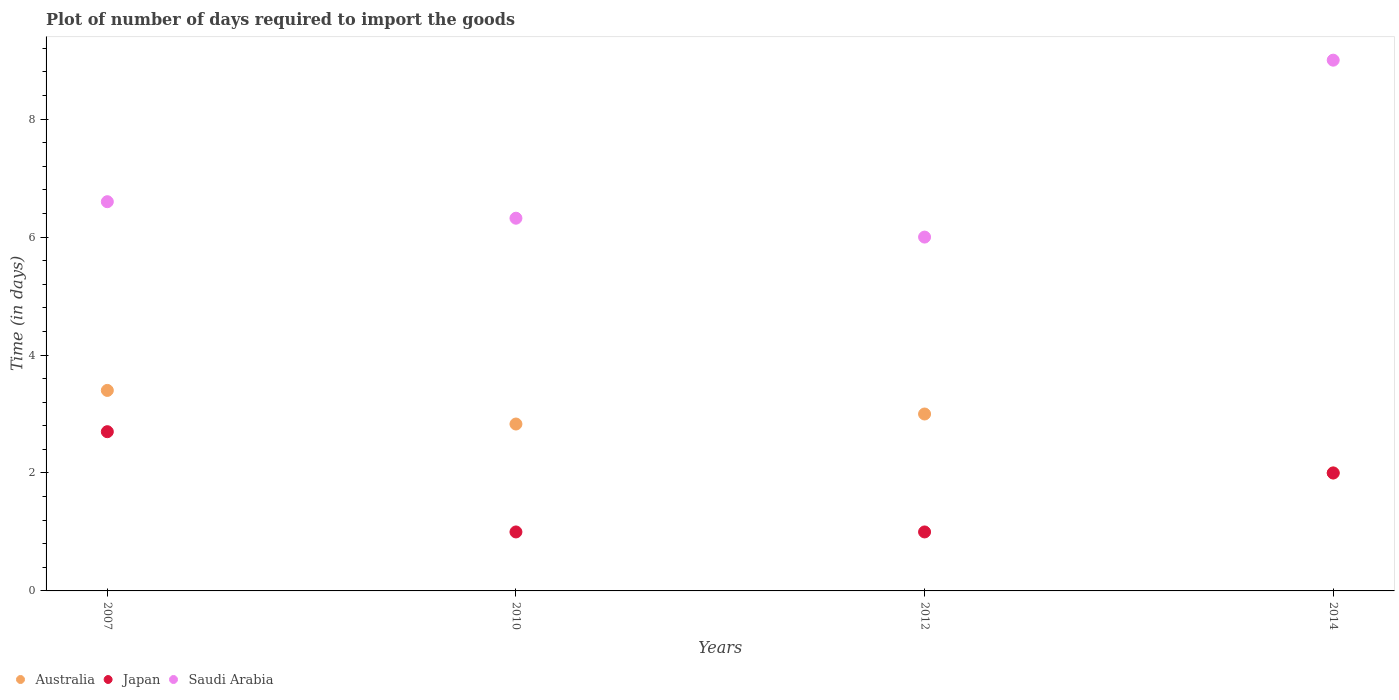How many different coloured dotlines are there?
Provide a short and direct response. 3. What is the time required to import goods in Australia in 2012?
Your answer should be very brief. 3. In which year was the time required to import goods in Australia minimum?
Provide a short and direct response. 2014. What is the total time required to import goods in Saudi Arabia in the graph?
Make the answer very short. 27.92. What is the difference between the time required to import goods in Japan in 2010 and that in 2014?
Offer a terse response. -1. What is the average time required to import goods in Saudi Arabia per year?
Your answer should be compact. 6.98. In the year 2012, what is the difference between the time required to import goods in Japan and time required to import goods in Saudi Arabia?
Ensure brevity in your answer.  -5. In how many years, is the time required to import goods in Australia greater than 4 days?
Provide a succinct answer. 0. What is the ratio of the time required to import goods in Saudi Arabia in 2007 to that in 2012?
Your answer should be compact. 1.1. Is the difference between the time required to import goods in Japan in 2010 and 2012 greater than the difference between the time required to import goods in Saudi Arabia in 2010 and 2012?
Provide a short and direct response. No. What is the difference between the highest and the second highest time required to import goods in Japan?
Offer a very short reply. 0.7. Is the sum of the time required to import goods in Saudi Arabia in 2007 and 2010 greater than the maximum time required to import goods in Australia across all years?
Provide a succinct answer. Yes. Is it the case that in every year, the sum of the time required to import goods in Australia and time required to import goods in Saudi Arabia  is greater than the time required to import goods in Japan?
Offer a very short reply. Yes. How many dotlines are there?
Give a very brief answer. 3. What is the difference between two consecutive major ticks on the Y-axis?
Offer a terse response. 2. Where does the legend appear in the graph?
Keep it short and to the point. Bottom left. How are the legend labels stacked?
Ensure brevity in your answer.  Horizontal. What is the title of the graph?
Your answer should be very brief. Plot of number of days required to import the goods. Does "High income: nonOECD" appear as one of the legend labels in the graph?
Give a very brief answer. No. What is the label or title of the Y-axis?
Offer a very short reply. Time (in days). What is the Time (in days) in Saudi Arabia in 2007?
Offer a terse response. 6.6. What is the Time (in days) in Australia in 2010?
Your answer should be very brief. 2.83. What is the Time (in days) of Japan in 2010?
Provide a short and direct response. 1. What is the Time (in days) in Saudi Arabia in 2010?
Make the answer very short. 6.32. What is the Time (in days) in Australia in 2012?
Give a very brief answer. 3. What is the Time (in days) in Japan in 2012?
Your answer should be very brief. 1. Across all years, what is the maximum Time (in days) in Saudi Arabia?
Ensure brevity in your answer.  9. Across all years, what is the minimum Time (in days) in Japan?
Give a very brief answer. 1. What is the total Time (in days) in Australia in the graph?
Give a very brief answer. 11.23. What is the total Time (in days) in Saudi Arabia in the graph?
Your answer should be very brief. 27.92. What is the difference between the Time (in days) in Australia in 2007 and that in 2010?
Offer a terse response. 0.57. What is the difference between the Time (in days) of Japan in 2007 and that in 2010?
Offer a very short reply. 1.7. What is the difference between the Time (in days) in Saudi Arabia in 2007 and that in 2010?
Provide a short and direct response. 0.28. What is the difference between the Time (in days) in Australia in 2007 and that in 2012?
Give a very brief answer. 0.4. What is the difference between the Time (in days) in Australia in 2007 and that in 2014?
Your answer should be very brief. 1.4. What is the difference between the Time (in days) of Saudi Arabia in 2007 and that in 2014?
Your answer should be compact. -2.4. What is the difference between the Time (in days) of Australia in 2010 and that in 2012?
Your answer should be compact. -0.17. What is the difference between the Time (in days) in Japan in 2010 and that in 2012?
Provide a succinct answer. 0. What is the difference between the Time (in days) in Saudi Arabia in 2010 and that in 2012?
Your answer should be very brief. 0.32. What is the difference between the Time (in days) in Australia in 2010 and that in 2014?
Your response must be concise. 0.83. What is the difference between the Time (in days) of Japan in 2010 and that in 2014?
Your response must be concise. -1. What is the difference between the Time (in days) of Saudi Arabia in 2010 and that in 2014?
Offer a very short reply. -2.68. What is the difference between the Time (in days) of Japan in 2012 and that in 2014?
Provide a short and direct response. -1. What is the difference between the Time (in days) in Australia in 2007 and the Time (in days) in Saudi Arabia in 2010?
Make the answer very short. -2.92. What is the difference between the Time (in days) in Japan in 2007 and the Time (in days) in Saudi Arabia in 2010?
Your answer should be very brief. -3.62. What is the difference between the Time (in days) of Australia in 2007 and the Time (in days) of Japan in 2012?
Keep it short and to the point. 2.4. What is the difference between the Time (in days) in Japan in 2007 and the Time (in days) in Saudi Arabia in 2014?
Your answer should be very brief. -6.3. What is the difference between the Time (in days) of Australia in 2010 and the Time (in days) of Japan in 2012?
Offer a terse response. 1.83. What is the difference between the Time (in days) of Australia in 2010 and the Time (in days) of Saudi Arabia in 2012?
Your response must be concise. -3.17. What is the difference between the Time (in days) of Japan in 2010 and the Time (in days) of Saudi Arabia in 2012?
Your response must be concise. -5. What is the difference between the Time (in days) in Australia in 2010 and the Time (in days) in Japan in 2014?
Make the answer very short. 0.83. What is the difference between the Time (in days) in Australia in 2010 and the Time (in days) in Saudi Arabia in 2014?
Keep it short and to the point. -6.17. What is the difference between the Time (in days) of Australia in 2012 and the Time (in days) of Japan in 2014?
Your answer should be very brief. 1. What is the difference between the Time (in days) of Australia in 2012 and the Time (in days) of Saudi Arabia in 2014?
Keep it short and to the point. -6. What is the average Time (in days) in Australia per year?
Offer a terse response. 2.81. What is the average Time (in days) in Japan per year?
Ensure brevity in your answer.  1.68. What is the average Time (in days) of Saudi Arabia per year?
Provide a succinct answer. 6.98. In the year 2010, what is the difference between the Time (in days) of Australia and Time (in days) of Japan?
Offer a very short reply. 1.83. In the year 2010, what is the difference between the Time (in days) in Australia and Time (in days) in Saudi Arabia?
Provide a succinct answer. -3.49. In the year 2010, what is the difference between the Time (in days) in Japan and Time (in days) in Saudi Arabia?
Keep it short and to the point. -5.32. In the year 2012, what is the difference between the Time (in days) in Australia and Time (in days) in Japan?
Give a very brief answer. 2. In the year 2012, what is the difference between the Time (in days) of Australia and Time (in days) of Saudi Arabia?
Provide a succinct answer. -3. In the year 2012, what is the difference between the Time (in days) of Japan and Time (in days) of Saudi Arabia?
Ensure brevity in your answer.  -5. In the year 2014, what is the difference between the Time (in days) in Australia and Time (in days) in Saudi Arabia?
Offer a very short reply. -7. What is the ratio of the Time (in days) of Australia in 2007 to that in 2010?
Make the answer very short. 1.2. What is the ratio of the Time (in days) in Japan in 2007 to that in 2010?
Keep it short and to the point. 2.7. What is the ratio of the Time (in days) of Saudi Arabia in 2007 to that in 2010?
Offer a very short reply. 1.04. What is the ratio of the Time (in days) of Australia in 2007 to that in 2012?
Offer a very short reply. 1.13. What is the ratio of the Time (in days) in Japan in 2007 to that in 2012?
Your response must be concise. 2.7. What is the ratio of the Time (in days) of Saudi Arabia in 2007 to that in 2012?
Your answer should be very brief. 1.1. What is the ratio of the Time (in days) in Australia in 2007 to that in 2014?
Your response must be concise. 1.7. What is the ratio of the Time (in days) of Japan in 2007 to that in 2014?
Your response must be concise. 1.35. What is the ratio of the Time (in days) of Saudi Arabia in 2007 to that in 2014?
Give a very brief answer. 0.73. What is the ratio of the Time (in days) of Australia in 2010 to that in 2012?
Provide a succinct answer. 0.94. What is the ratio of the Time (in days) of Saudi Arabia in 2010 to that in 2012?
Make the answer very short. 1.05. What is the ratio of the Time (in days) of Australia in 2010 to that in 2014?
Your answer should be compact. 1.42. What is the ratio of the Time (in days) in Saudi Arabia in 2010 to that in 2014?
Give a very brief answer. 0.7. What is the ratio of the Time (in days) of Australia in 2012 to that in 2014?
Offer a terse response. 1.5. What is the ratio of the Time (in days) in Japan in 2012 to that in 2014?
Make the answer very short. 0.5. What is the ratio of the Time (in days) in Saudi Arabia in 2012 to that in 2014?
Your answer should be very brief. 0.67. What is the difference between the highest and the second highest Time (in days) in Saudi Arabia?
Your answer should be compact. 2.4. What is the difference between the highest and the lowest Time (in days) in Australia?
Your response must be concise. 1.4. What is the difference between the highest and the lowest Time (in days) in Saudi Arabia?
Your response must be concise. 3. 